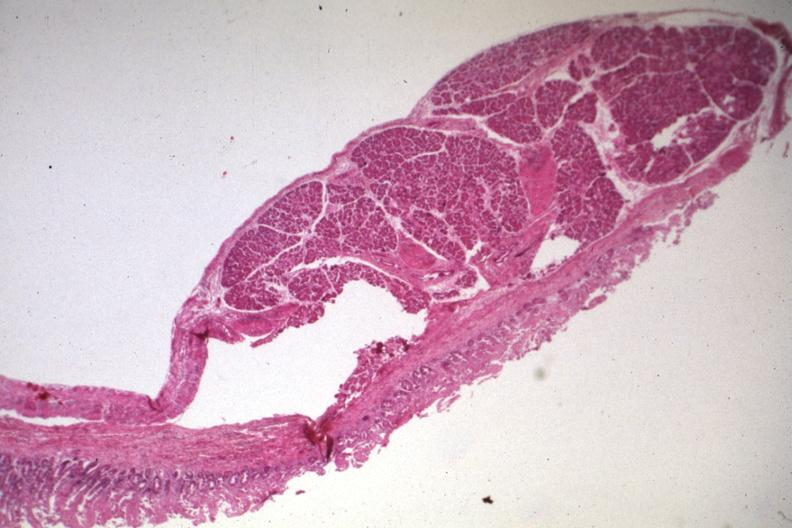does this image show quite good photo of ectopic pancreas?
Answer the question using a single word or phrase. Yes 